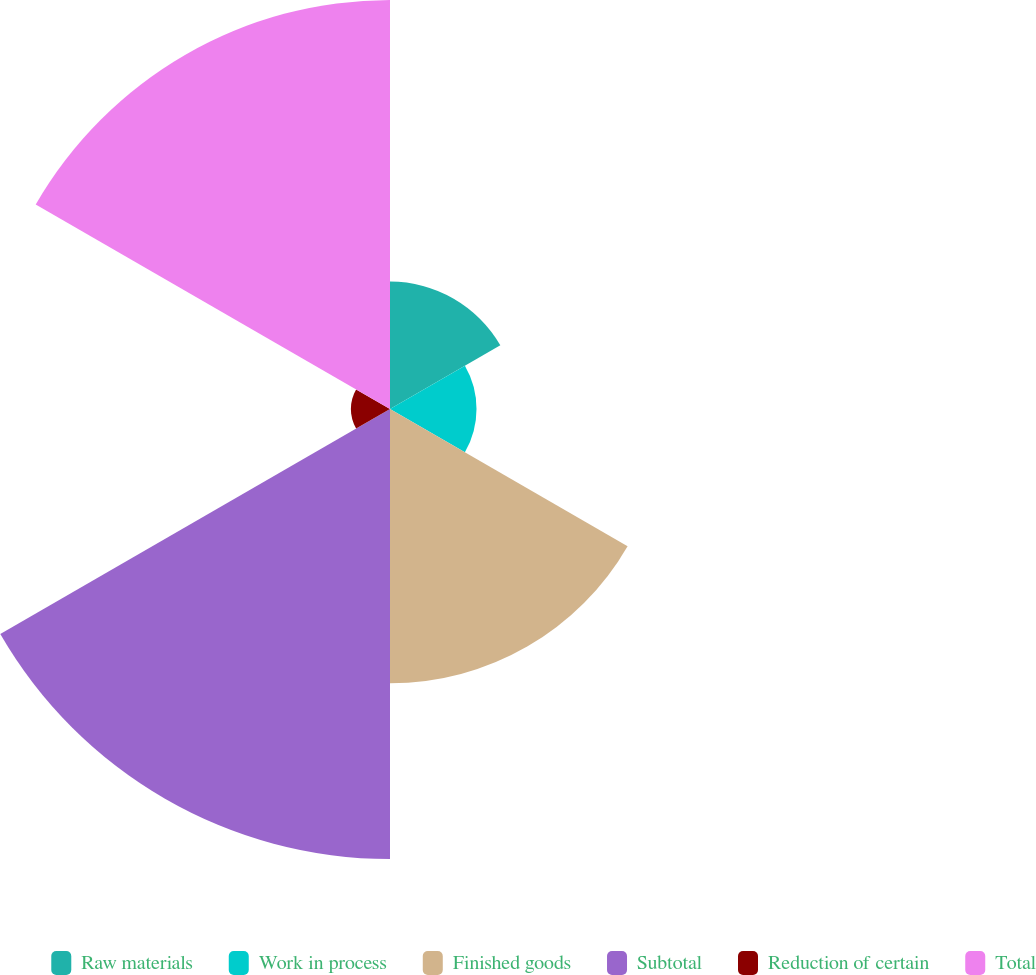<chart> <loc_0><loc_0><loc_500><loc_500><pie_chart><fcel>Raw materials<fcel>Work in process<fcel>Finished goods<fcel>Subtotal<fcel>Reduction of certain<fcel>Total<nl><fcel>9.19%<fcel>6.24%<fcel>19.79%<fcel>32.46%<fcel>2.82%<fcel>29.51%<nl></chart> 